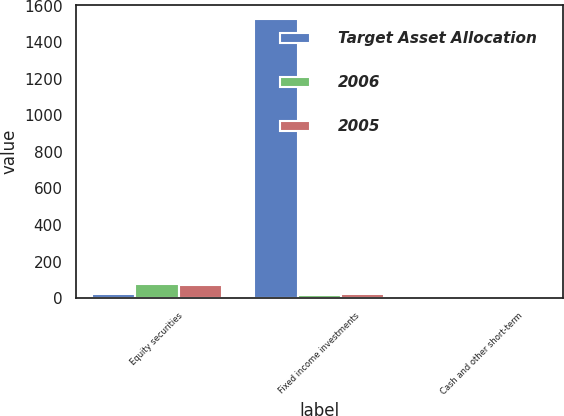<chart> <loc_0><loc_0><loc_500><loc_500><stacked_bar_chart><ecel><fcel>Equity securities<fcel>Fixed income investments<fcel>Cash and other short-term<nl><fcel>Target Asset Allocation<fcel>20.2<fcel>1525<fcel>5<nl><fcel>2006<fcel>79.4<fcel>18<fcel>2.6<nl><fcel>2005<fcel>74<fcel>22.4<fcel>3.6<nl></chart> 